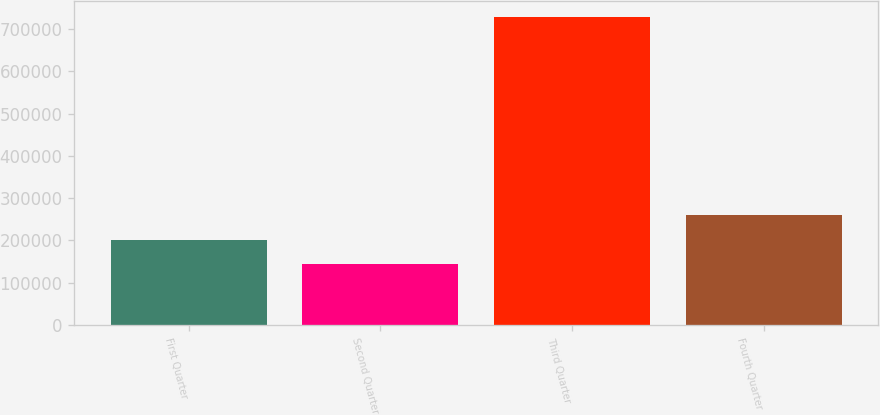<chart> <loc_0><loc_0><loc_500><loc_500><bar_chart><fcel>First Quarter<fcel>Second Quarter<fcel>Third Quarter<fcel>Fourth Quarter<nl><fcel>202105<fcel>143509<fcel>729469<fcel>260701<nl></chart> 